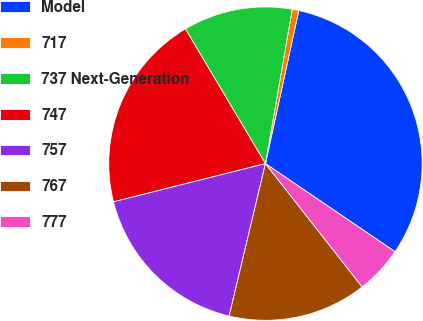Convert chart to OTSL. <chart><loc_0><loc_0><loc_500><loc_500><pie_chart><fcel>Model<fcel>717<fcel>737 Next-Generation<fcel>747<fcel>757<fcel>767<fcel>777<nl><fcel>31.09%<fcel>0.68%<fcel>11.27%<fcel>20.39%<fcel>17.35%<fcel>14.31%<fcel>4.91%<nl></chart> 